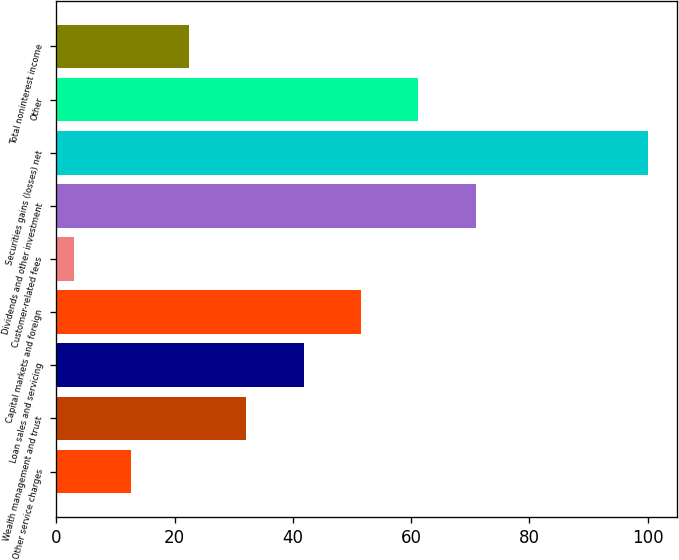<chart> <loc_0><loc_0><loc_500><loc_500><bar_chart><fcel>Other service charges<fcel>Wealth management and trust<fcel>Loan sales and servicing<fcel>Capital markets and foreign<fcel>Customer-related fees<fcel>Dividends and other investment<fcel>Securities gains (losses) net<fcel>Other<fcel>Total noninterest income<nl><fcel>12.7<fcel>32.1<fcel>41.8<fcel>51.5<fcel>3<fcel>70.9<fcel>100<fcel>61.2<fcel>22.4<nl></chart> 